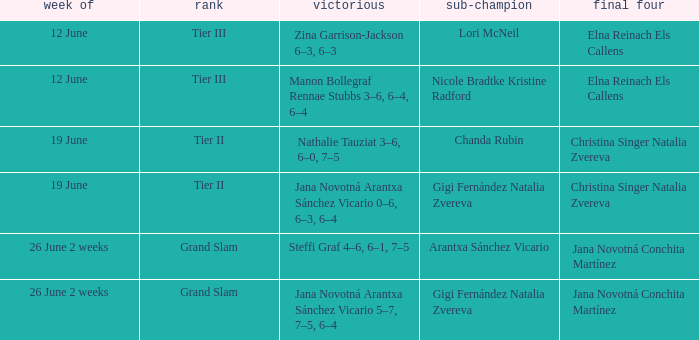Who is the winner in the week listed as 26 June 2 weeks, when the runner-up is Arantxa Sánchez Vicario? Steffi Graf 4–6, 6–1, 7–5. 